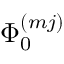<formula> <loc_0><loc_0><loc_500><loc_500>\Phi _ { 0 } ^ { ( m j ) }</formula> 